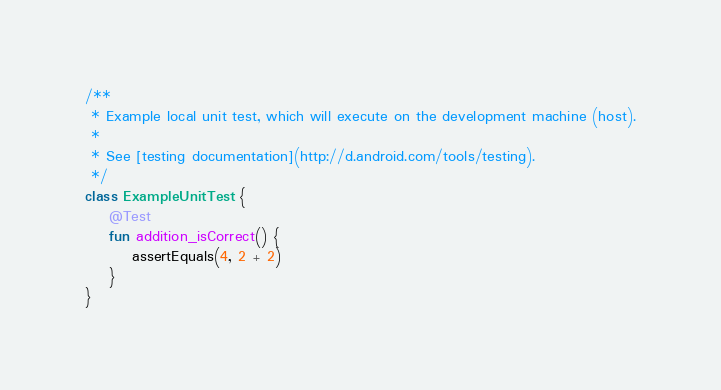Convert code to text. <code><loc_0><loc_0><loc_500><loc_500><_Kotlin_>
/**
 * Example local unit test, which will execute on the development machine (host).
 *
 * See [testing documentation](http://d.android.com/tools/testing).
 */
class ExampleUnitTest {
    @Test
    fun addition_isCorrect() {
        assertEquals(4, 2 + 2)
    }
}</code> 